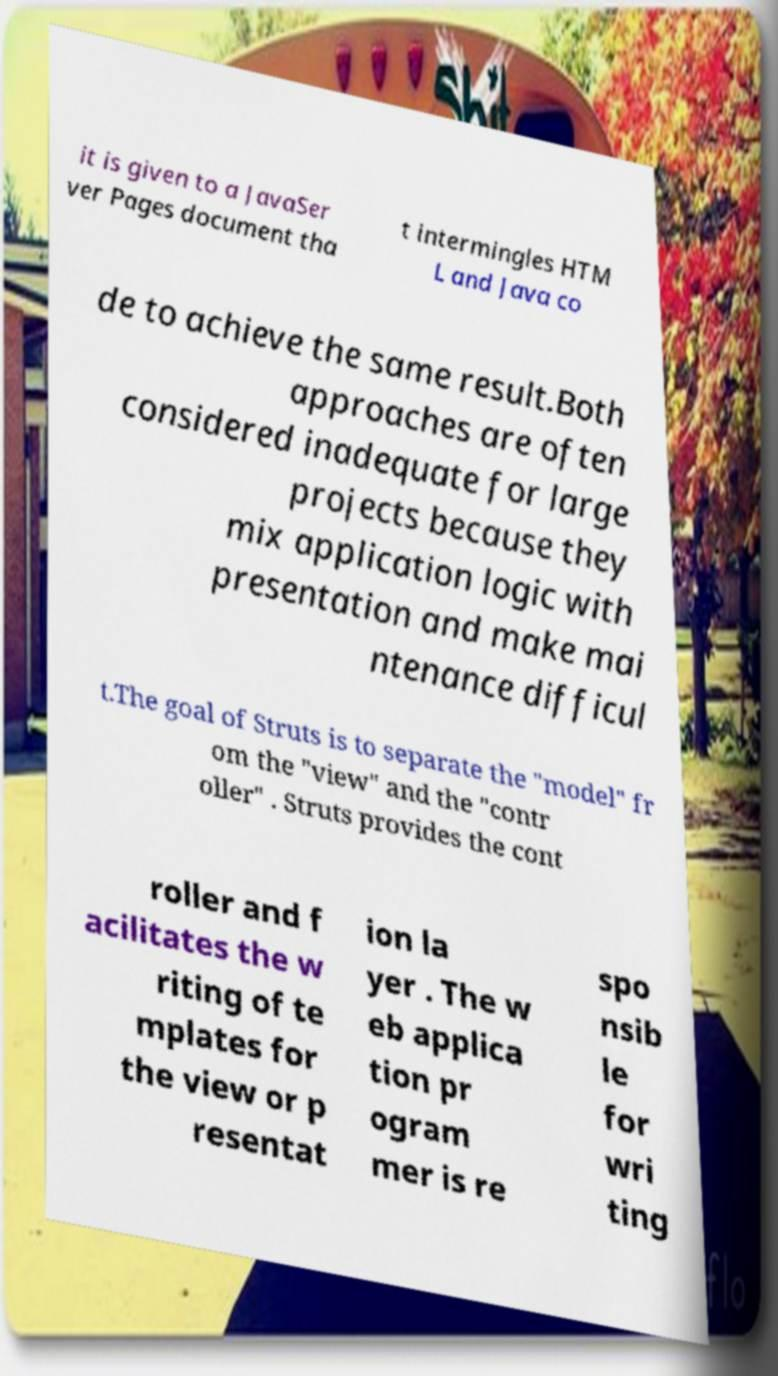What messages or text are displayed in this image? I need them in a readable, typed format. it is given to a JavaSer ver Pages document tha t intermingles HTM L and Java co de to achieve the same result.Both approaches are often considered inadequate for large projects because they mix application logic with presentation and make mai ntenance difficul t.The goal of Struts is to separate the "model" fr om the "view" and the "contr oller" . Struts provides the cont roller and f acilitates the w riting of te mplates for the view or p resentat ion la yer . The w eb applica tion pr ogram mer is re spo nsib le for wri ting 